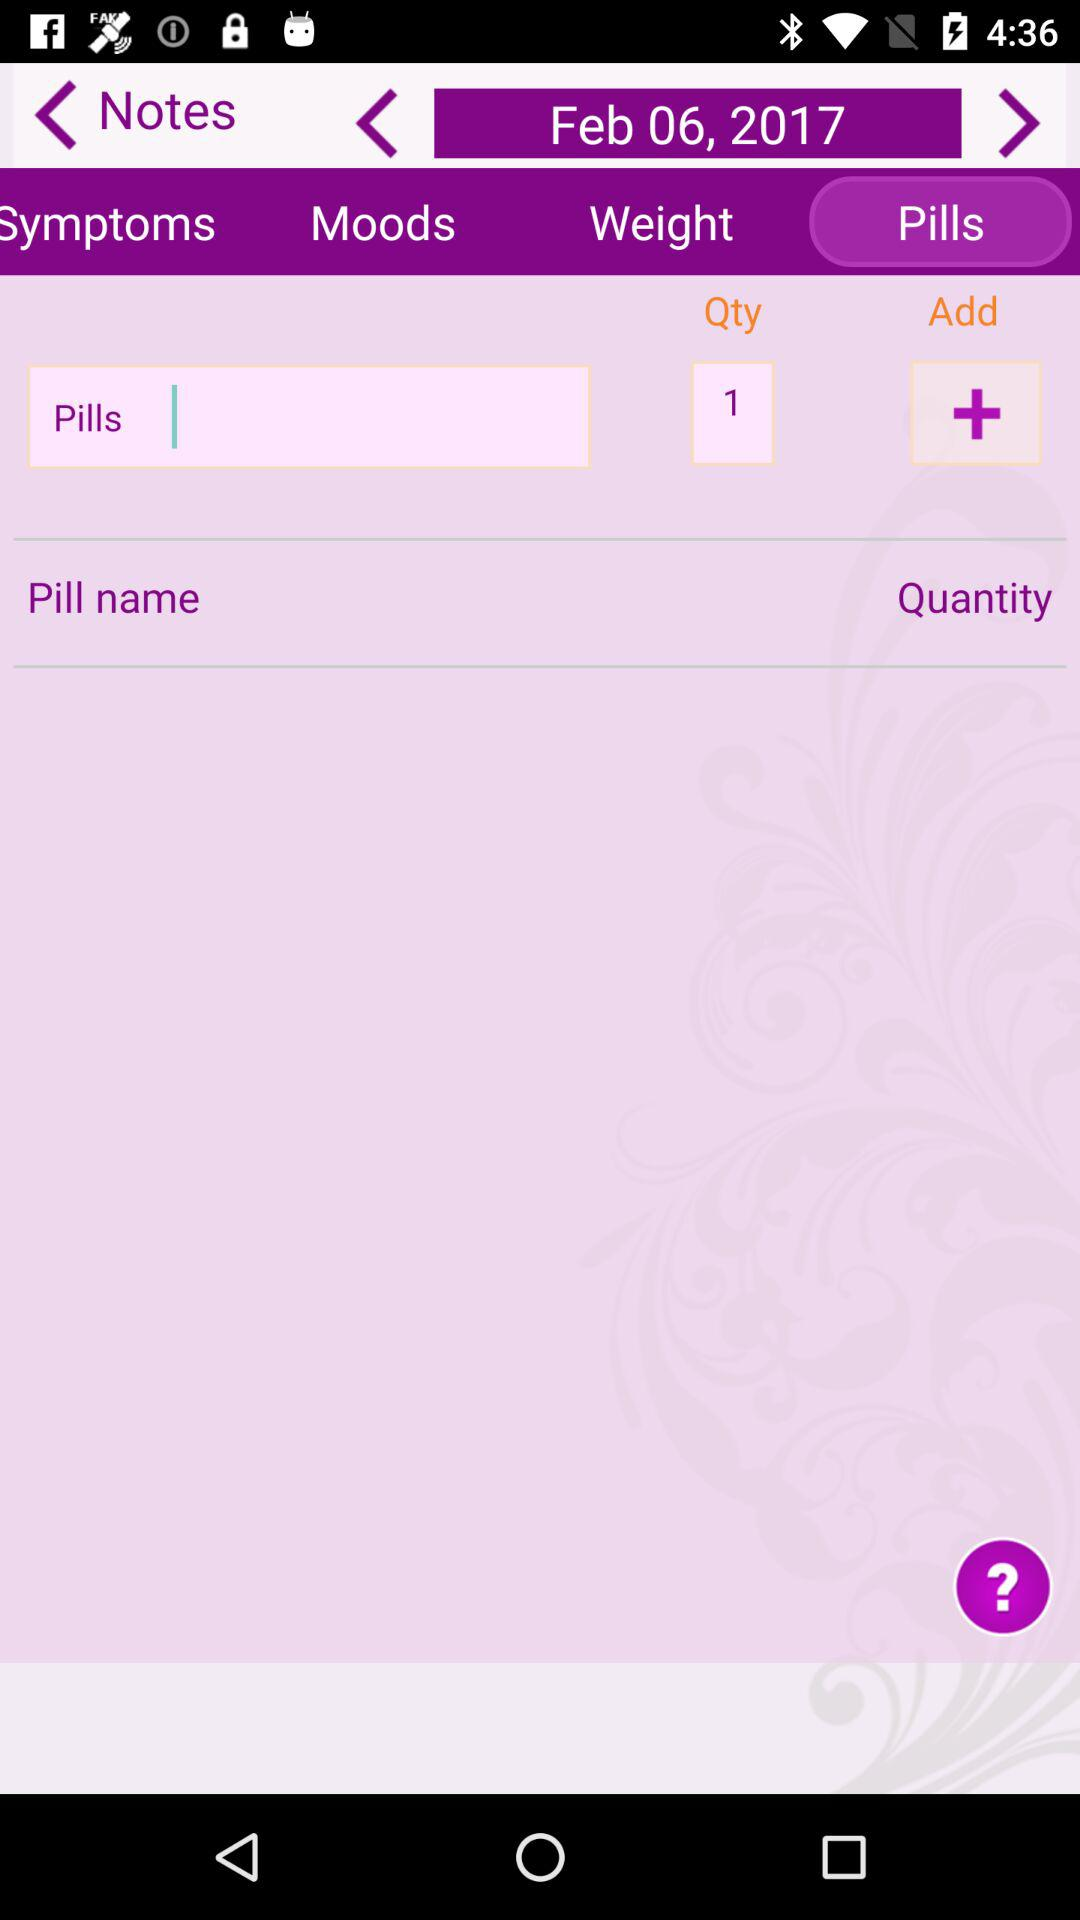Which tab is selected? The selected tab is "Pills". 